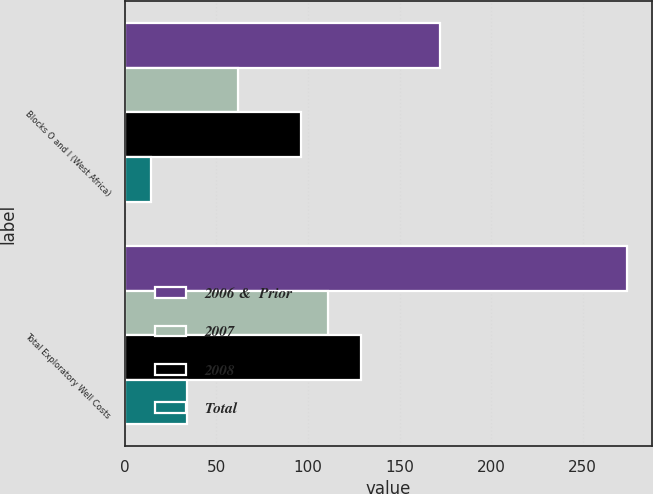Convert chart to OTSL. <chart><loc_0><loc_0><loc_500><loc_500><stacked_bar_chart><ecel><fcel>Blocks O and I (West Africa)<fcel>Total Exploratory Well Costs<nl><fcel>2006 &  Prior<fcel>172<fcel>274<nl><fcel>2007<fcel>62<fcel>111<nl><fcel>2008<fcel>96<fcel>129<nl><fcel>Total<fcel>14<fcel>34<nl></chart> 